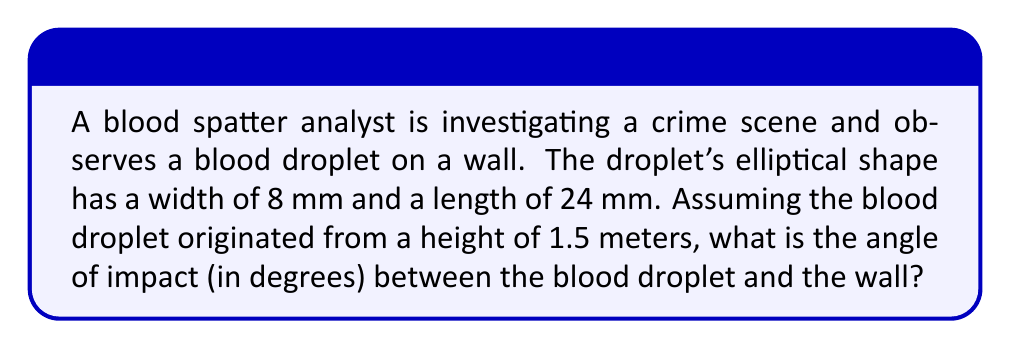Teach me how to tackle this problem. To solve this problem, we'll use the principles of trigonometry and blood spatter analysis. The angle of impact can be determined using the width-to-length ratio of the blood droplet.

1. Calculate the width-to-length ratio:
   $\text{Ratio} = \frac{\text{Width}}{\text{Length}} = \frac{8 \text{ mm}}{24 \text{ mm}} = \frac{1}{3}$

2. The angle of impact is the arcsine (inverse sine) of this ratio:
   $\text{Angle of impact} = \arcsin(\text{Ratio})$

3. Using the arcsine function:
   $\text{Angle of impact} = \arcsin(\frac{1}{3})$

4. Calculate the result:
   $\text{Angle of impact} \approx 19.47^\circ$

[asy]
import geometry;

size(200);

pair A = (0,0);
pair B = (100,0);
pair C = (100,35);

draw(A--B--C--A);

label("Wall", (50,0), S);
label("Blood droplet", (100,17.5), E);

draw(arc(B,10,0,19.47), Arrow);
label("19.47°", (95,7), NE);

draw((95,0)--(105,0), Arrow);
draw((100,0)--(100,35), Arrow);

label("8 mm", (100,17.5), W);
label("24 mm", (97.5,35), N);
[/asy]

The angle of impact is approximately 19.47°. This means the blood droplet struck the wall at an angle of 19.47° from the wall's surface.

Note: In real-world scenarios, other factors such as surface texture, blood viscosity, and air resistance might affect the accuracy of this calculation. However, this simplified model provides a good estimate for crime scene reconstruction purposes.
Answer: The angle of impact between the blood droplet and the wall is approximately $19.47^\circ$. 